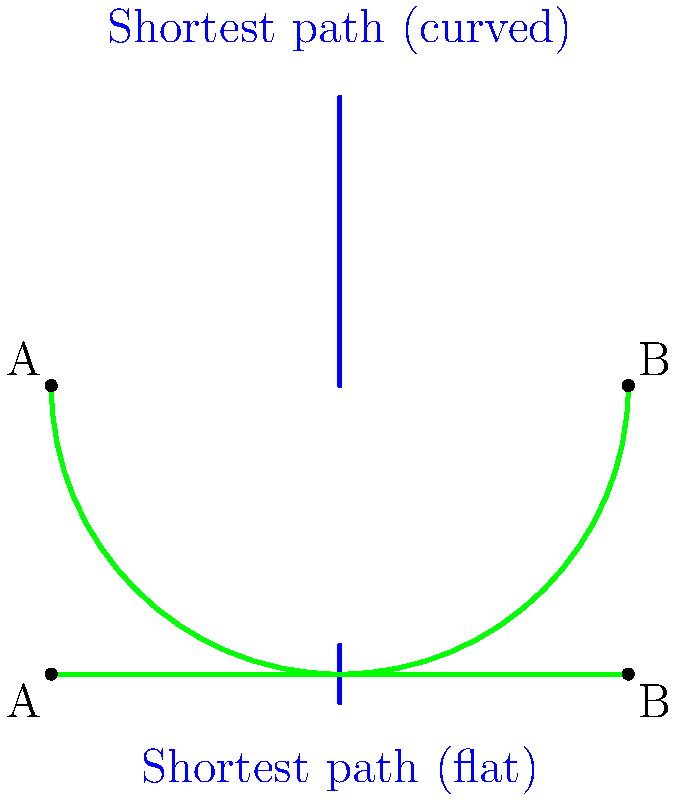As a ghostwriter collaborating with a retired professional golfer, you're discussing the importance of understanding green geometry. Consider a flat putting green and a curved putting green, both with points A and B at the same distance apart. How does the shortest path between A and B differ on these two surfaces, and what implications does this have for a golfer's strategy? To understand the difference in the shortest paths, let's analyze each surface:

1. Flat putting green:
   - On a flat surface, the shortest path between two points is always a straight line.
   - The distance is simply the Euclidean distance between A and B.
   - Mathematically, if the distance between A and B is $d$, the path length is $d$.

2. Curved putting green:
   - On a curved surface (like a sphere or part of a sphere), the shortest path is a geodesic.
   - For a spherical surface, this geodesic is part of a great circle (the intersection of the sphere with a plane passing through its center).
   - The path length is longer than the straight-line distance between the same points on a flat surface.
   - If the green is part of a sphere with radius $R$, and the central angle between A and B is $\theta$ (in radians), the path length is $R\theta$.

3. Implications for golf strategy:
   - On a flat green, the golfer can aim directly at the hole (assuming no other factors).
   - On a curved green, the golfer must account for the curvature:
     a) The ball will follow a curved path (geodesic) even if hit "straight."
     b) The distance to the hole is effectively longer than it appears.
     c) The golfer may need to aim slightly away from the hole to follow the curve of the green.

4. Mathematical comparison:
   - Let's say the straight-line distance between A and B is 10 feet, and the green has a radius of curvature of 100 feet.
   - On the flat green, the path length is 10 feet.
   - On the curved green, we can calculate $\theta = \frac{10}{100} = 0.1$ radians.
   - The curved path length is then $100 * 0.1 = 10.05$ feet.
   - While the difference seems small, it can be significant in professional golf where precision is key.

Understanding this geometry helps golfers "read" the green more accurately and plan their putts accordingly.
Answer: The shortest path on a flat green is a straight line, while on a curved green it's a geodesic (curved path). This affects aiming and distance perception in putting. 